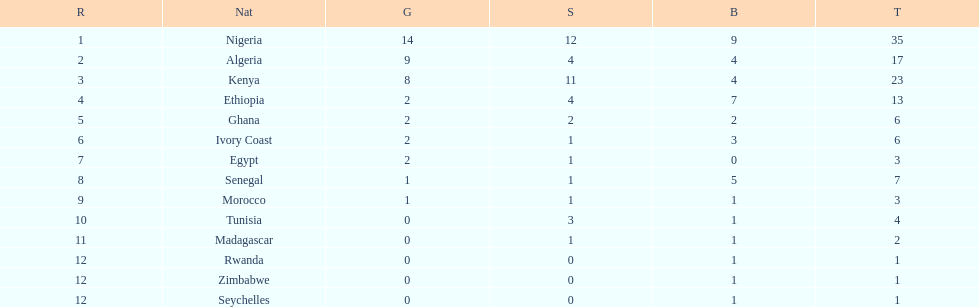Can you parse all the data within this table? {'header': ['R', 'Nat', 'G', 'S', 'B', 'T'], 'rows': [['1', 'Nigeria', '14', '12', '9', '35'], ['2', 'Algeria', '9', '4', '4', '17'], ['3', 'Kenya', '8', '11', '4', '23'], ['4', 'Ethiopia', '2', '4', '7', '13'], ['5', 'Ghana', '2', '2', '2', '6'], ['6', 'Ivory Coast', '2', '1', '3', '6'], ['7', 'Egypt', '2', '1', '0', '3'], ['8', 'Senegal', '1', '1', '5', '7'], ['9', 'Morocco', '1', '1', '1', '3'], ['10', 'Tunisia', '0', '3', '1', '4'], ['11', 'Madagascar', '0', '1', '1', '2'], ['12', 'Rwanda', '0', '0', '1', '1'], ['12', 'Zimbabwe', '0', '0', '1', '1'], ['12', 'Seychelles', '0', '0', '1', '1']]} What was the total number of medals the ivory coast won? 6. 